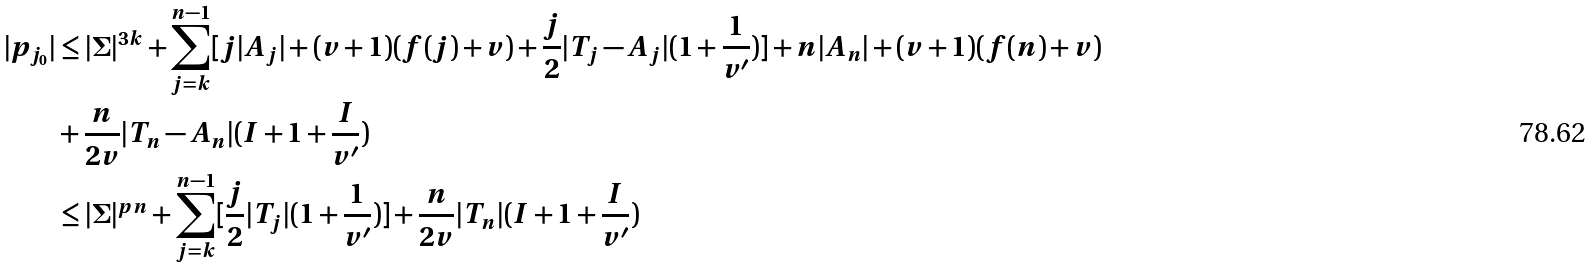Convert formula to latex. <formula><loc_0><loc_0><loc_500><loc_500>| p _ { j _ { 0 } } | & \leq | \Sigma | ^ { 3 k } + \sum _ { j = k } ^ { n - 1 } [ j | A _ { j } | + ( v + 1 ) ( f ( j ) + v ) + \frac { j } { 2 } | T _ { j } - A _ { j } | ( 1 + \frac { 1 } { v ^ { \prime } } ) ] + n | A _ { n } | + ( v + 1 ) ( f ( n ) + v ) \\ & + \frac { n } { 2 v } | T _ { n } - A _ { n } | ( I + 1 + \frac { I } { v ^ { \prime } } ) \\ & \leq | \Sigma | ^ { p n } + \sum _ { j = k } ^ { n - 1 } [ \frac { j } { 2 } | T _ { j } | ( 1 + \frac { 1 } { v ^ { \prime } } ) ] + \frac { n } { 2 v } | T _ { n } | ( I + 1 + \frac { I } { v ^ { \prime } } )</formula> 